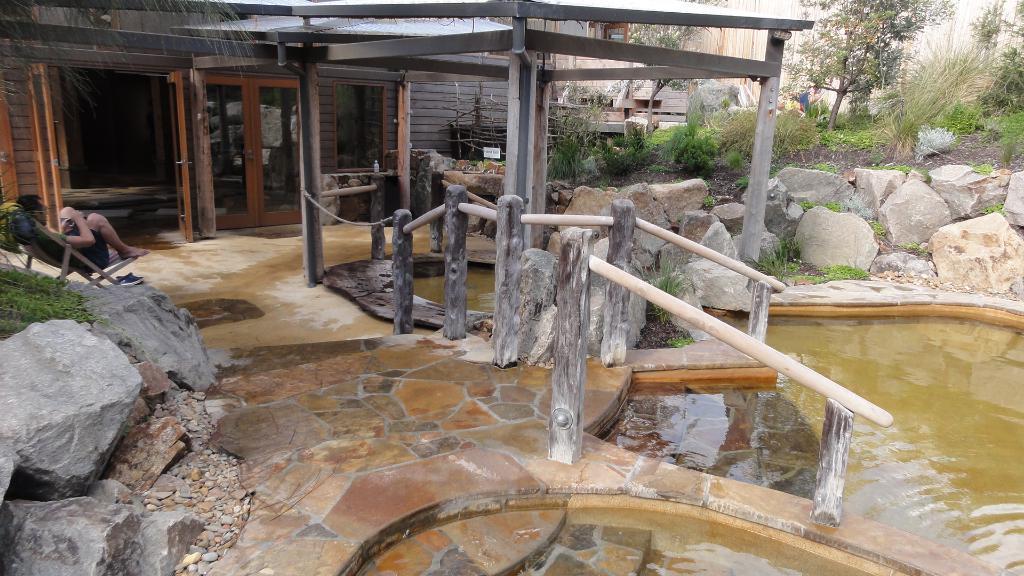Please provide a concise description of this image. In this image we can see a person sitting on the chair, barrier poles, rocks, shrubs, plants, trees, stones and a building. 